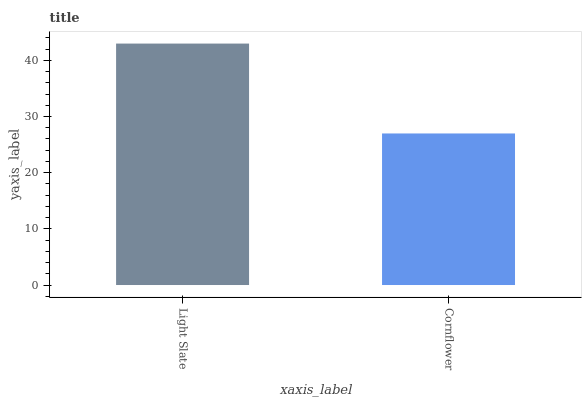Is Cornflower the minimum?
Answer yes or no. Yes. Is Light Slate the maximum?
Answer yes or no. Yes. Is Cornflower the maximum?
Answer yes or no. No. Is Light Slate greater than Cornflower?
Answer yes or no. Yes. Is Cornflower less than Light Slate?
Answer yes or no. Yes. Is Cornflower greater than Light Slate?
Answer yes or no. No. Is Light Slate less than Cornflower?
Answer yes or no. No. Is Light Slate the high median?
Answer yes or no. Yes. Is Cornflower the low median?
Answer yes or no. Yes. Is Cornflower the high median?
Answer yes or no. No. Is Light Slate the low median?
Answer yes or no. No. 